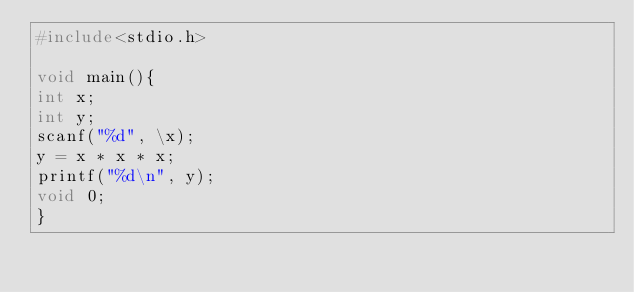Convert code to text. <code><loc_0><loc_0><loc_500><loc_500><_C_>#include<stdio.h>
 
void main(){
int x;
int y;
scanf("%d", \x);
y = x * x * x;
printf("%d\n", y);
void 0;
}</code> 